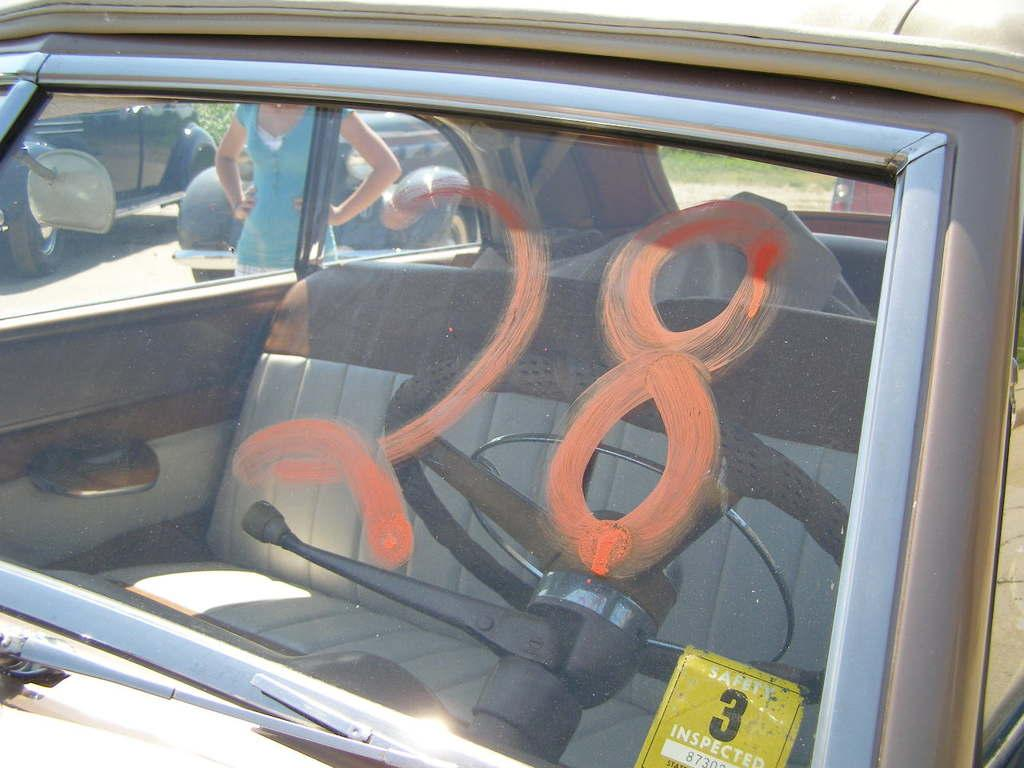What type of vehicles can be seen in the image? There are cars in the image. Can you describe the woman's position in relation to the car? There is a woman beside a car in the image. What type of natural environment is visible in the background of the image? There is grass visible in the background of the image. What type of boot is the woman wearing in the image? There is no information about the woman's footwear in the image, so it cannot be determined. 